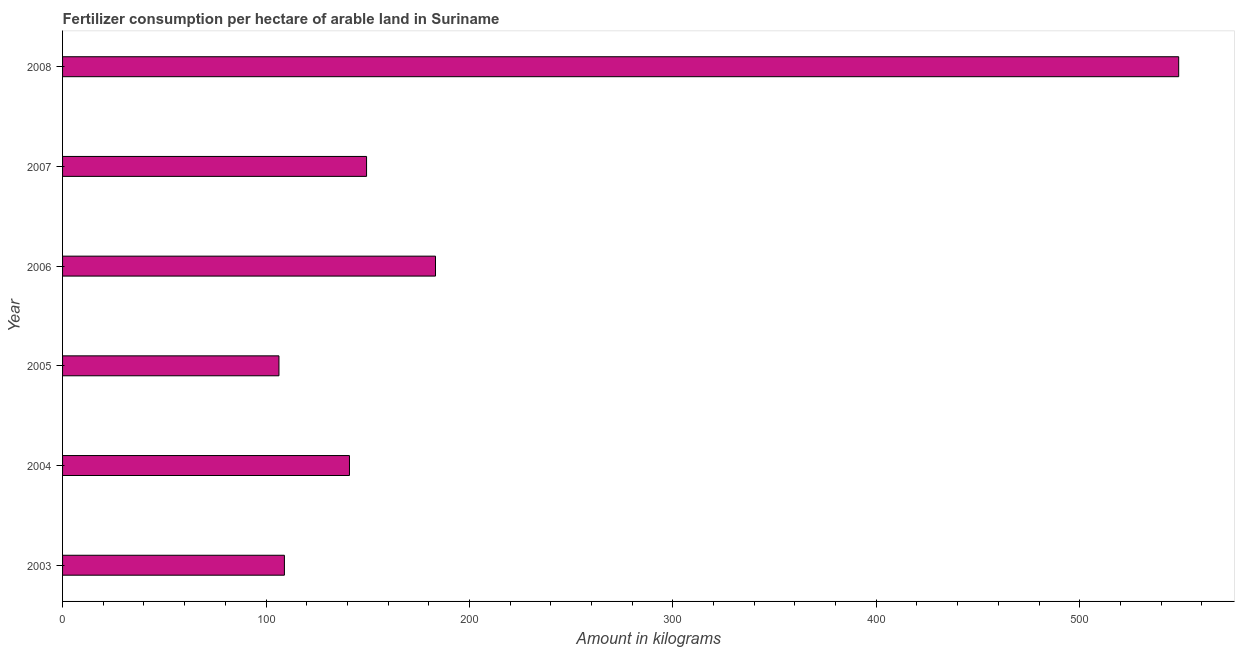What is the title of the graph?
Your answer should be compact. Fertilizer consumption per hectare of arable land in Suriname . What is the label or title of the X-axis?
Your response must be concise. Amount in kilograms. What is the amount of fertilizer consumption in 2008?
Keep it short and to the point. 548.66. Across all years, what is the maximum amount of fertilizer consumption?
Provide a short and direct response. 548.66. Across all years, what is the minimum amount of fertilizer consumption?
Provide a succinct answer. 106.37. In which year was the amount of fertilizer consumption minimum?
Keep it short and to the point. 2005. What is the sum of the amount of fertilizer consumption?
Provide a succinct answer. 1237.88. What is the difference between the amount of fertilizer consumption in 2006 and 2008?
Give a very brief answer. -365.33. What is the average amount of fertilizer consumption per year?
Provide a short and direct response. 206.31. What is the median amount of fertilizer consumption?
Offer a very short reply. 145.24. What is the ratio of the amount of fertilizer consumption in 2004 to that in 2007?
Your answer should be very brief. 0.94. What is the difference between the highest and the second highest amount of fertilizer consumption?
Provide a succinct answer. 365.33. Is the sum of the amount of fertilizer consumption in 2003 and 2004 greater than the maximum amount of fertilizer consumption across all years?
Your answer should be compact. No. What is the difference between the highest and the lowest amount of fertilizer consumption?
Keep it short and to the point. 442.29. In how many years, is the amount of fertilizer consumption greater than the average amount of fertilizer consumption taken over all years?
Provide a short and direct response. 1. How many bars are there?
Your answer should be very brief. 6. How many years are there in the graph?
Provide a succinct answer. 6. What is the difference between two consecutive major ticks on the X-axis?
Give a very brief answer. 100. What is the Amount in kilograms of 2003?
Make the answer very short. 109.05. What is the Amount in kilograms of 2004?
Keep it short and to the point. 141.04. What is the Amount in kilograms in 2005?
Ensure brevity in your answer.  106.37. What is the Amount in kilograms of 2006?
Give a very brief answer. 183.33. What is the Amount in kilograms of 2007?
Ensure brevity in your answer.  149.43. What is the Amount in kilograms of 2008?
Make the answer very short. 548.66. What is the difference between the Amount in kilograms in 2003 and 2004?
Offer a very short reply. -31.98. What is the difference between the Amount in kilograms in 2003 and 2005?
Your answer should be very brief. 2.69. What is the difference between the Amount in kilograms in 2003 and 2006?
Offer a very short reply. -74.27. What is the difference between the Amount in kilograms in 2003 and 2007?
Your answer should be compact. -40.38. What is the difference between the Amount in kilograms in 2003 and 2008?
Your response must be concise. -439.61. What is the difference between the Amount in kilograms in 2004 and 2005?
Offer a terse response. 34.67. What is the difference between the Amount in kilograms in 2004 and 2006?
Your response must be concise. -42.29. What is the difference between the Amount in kilograms in 2004 and 2007?
Make the answer very short. -8.4. What is the difference between the Amount in kilograms in 2004 and 2008?
Provide a short and direct response. -407.62. What is the difference between the Amount in kilograms in 2005 and 2006?
Make the answer very short. -76.96. What is the difference between the Amount in kilograms in 2005 and 2007?
Ensure brevity in your answer.  -43.07. What is the difference between the Amount in kilograms in 2005 and 2008?
Keep it short and to the point. -442.29. What is the difference between the Amount in kilograms in 2006 and 2007?
Keep it short and to the point. 33.89. What is the difference between the Amount in kilograms in 2006 and 2008?
Offer a terse response. -365.33. What is the difference between the Amount in kilograms in 2007 and 2008?
Your response must be concise. -399.22. What is the ratio of the Amount in kilograms in 2003 to that in 2004?
Give a very brief answer. 0.77. What is the ratio of the Amount in kilograms in 2003 to that in 2005?
Ensure brevity in your answer.  1.02. What is the ratio of the Amount in kilograms in 2003 to that in 2006?
Your answer should be very brief. 0.59. What is the ratio of the Amount in kilograms in 2003 to that in 2007?
Offer a very short reply. 0.73. What is the ratio of the Amount in kilograms in 2003 to that in 2008?
Your response must be concise. 0.2. What is the ratio of the Amount in kilograms in 2004 to that in 2005?
Provide a short and direct response. 1.33. What is the ratio of the Amount in kilograms in 2004 to that in 2006?
Your answer should be compact. 0.77. What is the ratio of the Amount in kilograms in 2004 to that in 2007?
Provide a succinct answer. 0.94. What is the ratio of the Amount in kilograms in 2004 to that in 2008?
Provide a succinct answer. 0.26. What is the ratio of the Amount in kilograms in 2005 to that in 2006?
Make the answer very short. 0.58. What is the ratio of the Amount in kilograms in 2005 to that in 2007?
Keep it short and to the point. 0.71. What is the ratio of the Amount in kilograms in 2005 to that in 2008?
Give a very brief answer. 0.19. What is the ratio of the Amount in kilograms in 2006 to that in 2007?
Offer a terse response. 1.23. What is the ratio of the Amount in kilograms in 2006 to that in 2008?
Provide a succinct answer. 0.33. What is the ratio of the Amount in kilograms in 2007 to that in 2008?
Offer a terse response. 0.27. 